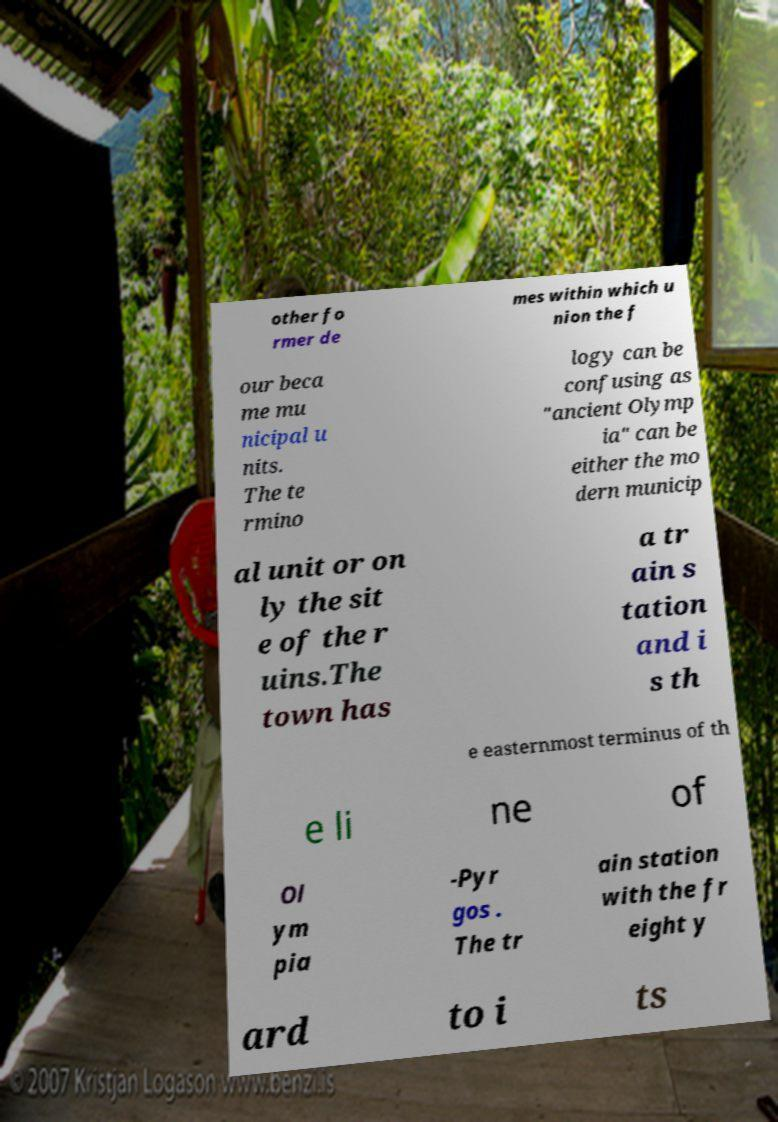For documentation purposes, I need the text within this image transcribed. Could you provide that? other fo rmer de mes within which u nion the f our beca me mu nicipal u nits. The te rmino logy can be confusing as "ancient Olymp ia" can be either the mo dern municip al unit or on ly the sit e of the r uins.The town has a tr ain s tation and i s th e easternmost terminus of th e li ne of Ol ym pia -Pyr gos . The tr ain station with the fr eight y ard to i ts 